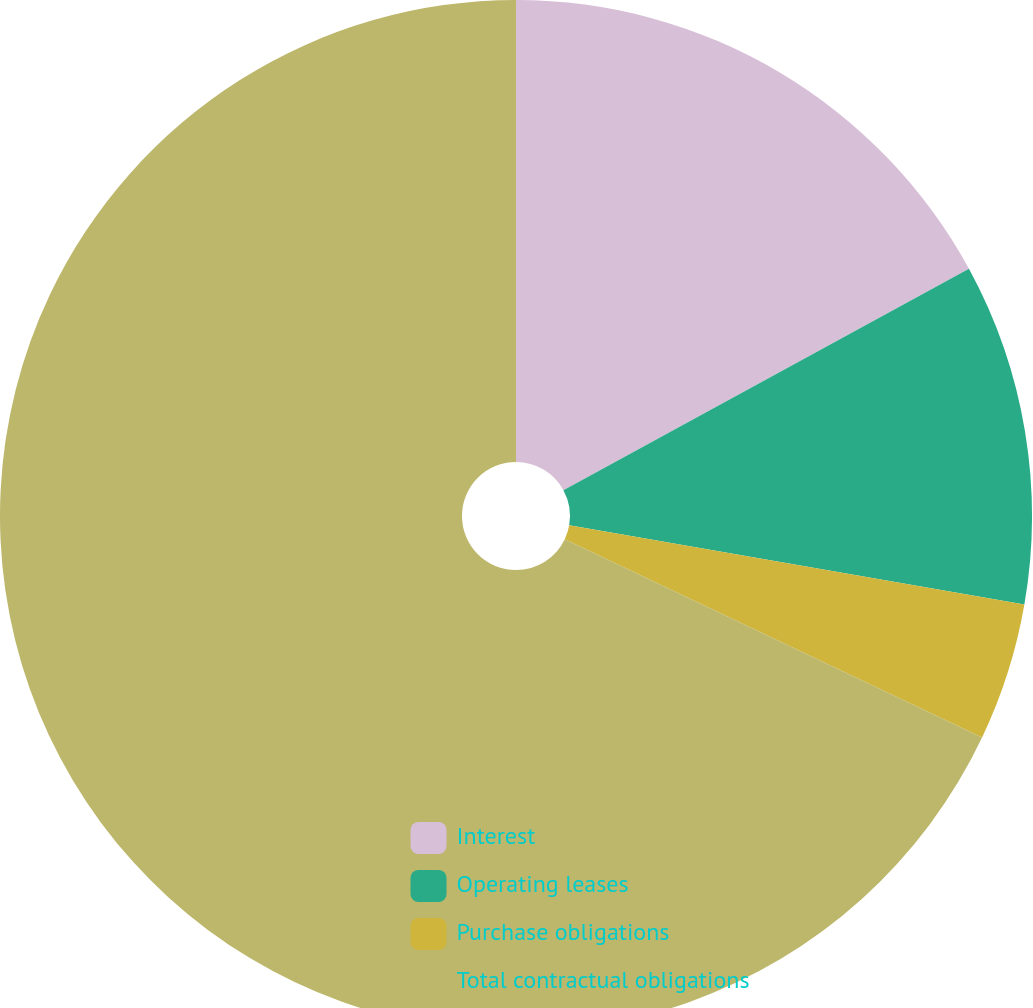<chart> <loc_0><loc_0><loc_500><loc_500><pie_chart><fcel>Interest<fcel>Operating leases<fcel>Purchase obligations<fcel>Total contractual obligations<nl><fcel>17.05%<fcel>10.69%<fcel>4.32%<fcel>67.94%<nl></chart> 